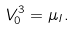Convert formula to latex. <formula><loc_0><loc_0><loc_500><loc_500>V _ { 0 } ^ { 3 } = \mu _ { I } .</formula> 